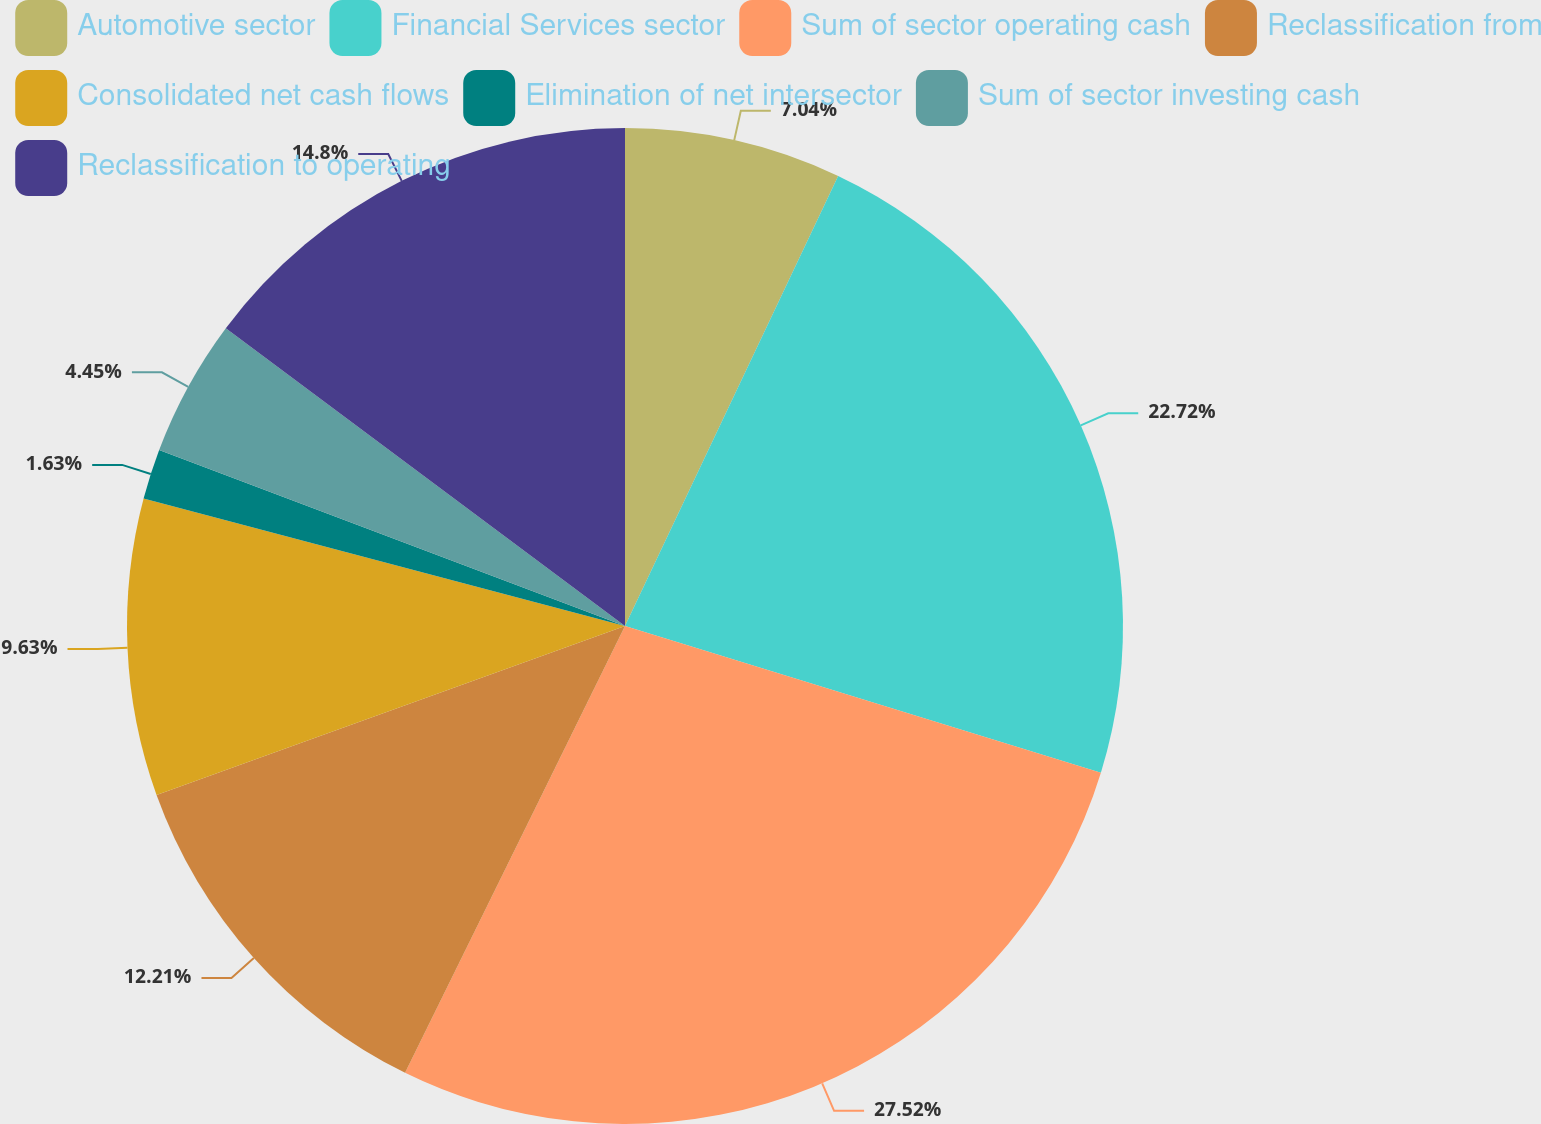<chart> <loc_0><loc_0><loc_500><loc_500><pie_chart><fcel>Automotive sector<fcel>Financial Services sector<fcel>Sum of sector operating cash<fcel>Reclassification from<fcel>Consolidated net cash flows<fcel>Elimination of net intersector<fcel>Sum of sector investing cash<fcel>Reclassification to operating<nl><fcel>7.04%<fcel>22.72%<fcel>27.52%<fcel>12.21%<fcel>9.63%<fcel>1.63%<fcel>4.45%<fcel>14.8%<nl></chart> 